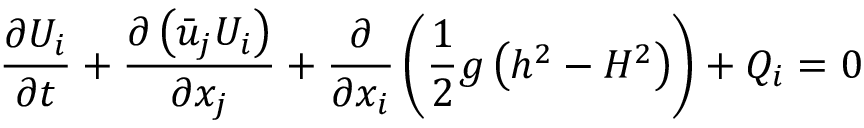<formula> <loc_0><loc_0><loc_500><loc_500>\frac { \partial { { U } _ { i } } } { \partial t } + \frac { \partial \left ( { { { \bar { u } } } _ { j } } { { U } _ { i } } \right ) } { \partial { { x } _ { j } } } + \frac { \partial } { \partial { { x } _ { i } } } \left ( \frac { 1 } { 2 } g \left ( { { h } ^ { 2 } } - { { H } ^ { 2 } } \right ) \right ) + { { Q } _ { i } } = 0</formula> 